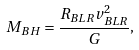<formula> <loc_0><loc_0><loc_500><loc_500>M _ { B H } = \frac { R _ { B L R } v _ { B L R } ^ { 2 } } { G } ,</formula> 